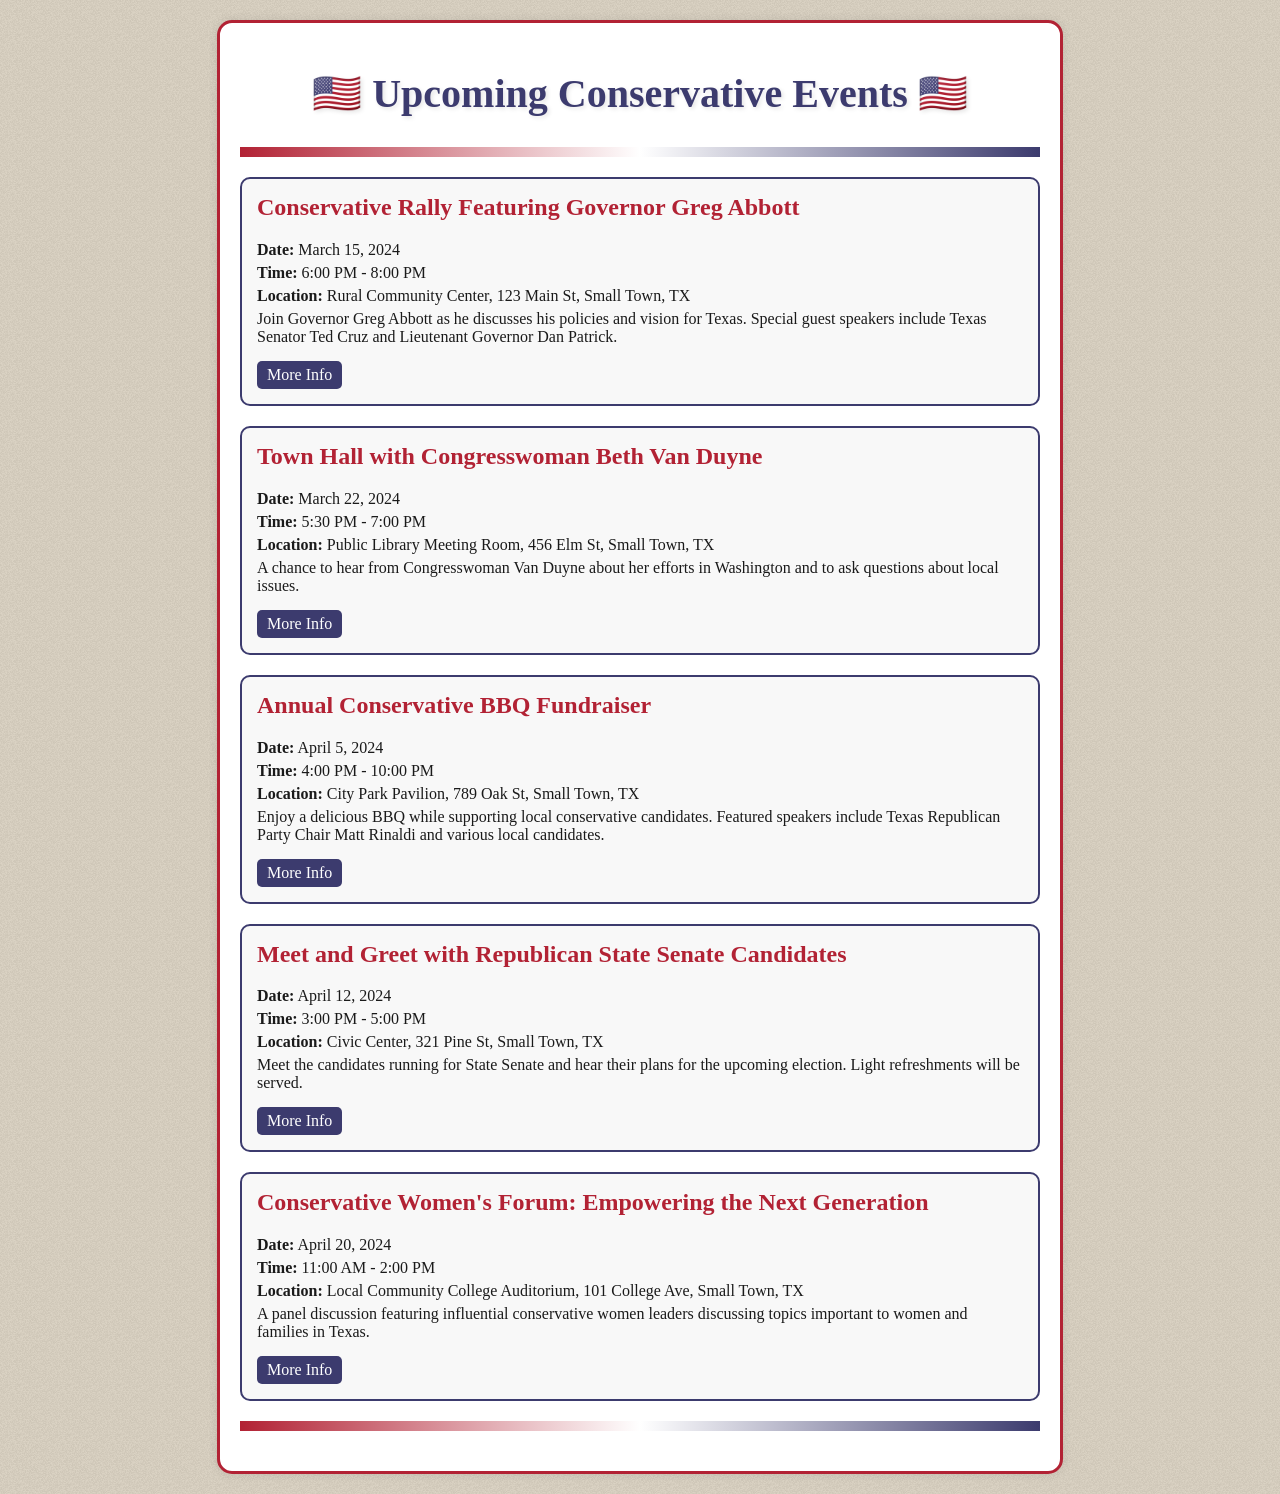What is the date of the Conservative Rally? The date of the Conservative Rally is explicitly mentioned in the event details.
Answer: March 15, 2024 Who is the special guest at the Conservative Rally? The special guest is listed in the event description along with the event name.
Answer: Ted Cruz What time does the Town Hall with Beth Van Duyne start? The starting time of the Town Hall is provided in the event details.
Answer: 5:30 PM Where is the Annual Conservative BBQ Fundraiser held? The location of the BBQ Fundraiser is specified in the event description.
Answer: City Park Pavilion, 789 Oak St, Small Town, TX How many events are listed for April? To find this, count the events scheduled in the month of April from the document.
Answer: Three What is the focus of the Conservative Women's Forum? The focus is mentioned in the event description outlining what the panel discussion will cover.
Answer: Empowering the Next Generation What is the duration of the Meet and Greet event? This can be found by calculating the time difference between start and end times listed in the event.
Answer: 2 hours Who is the chair of the Texas Republican Party speaking at the BBQ? The name of the chair is mentioned in relation to the BBQ event details.
Answer: Matt Rinaldi When is the last event scheduled in the document? The date of the last event can be seen by looking at the dates mentioned in the events.
Answer: April 20, 2024 